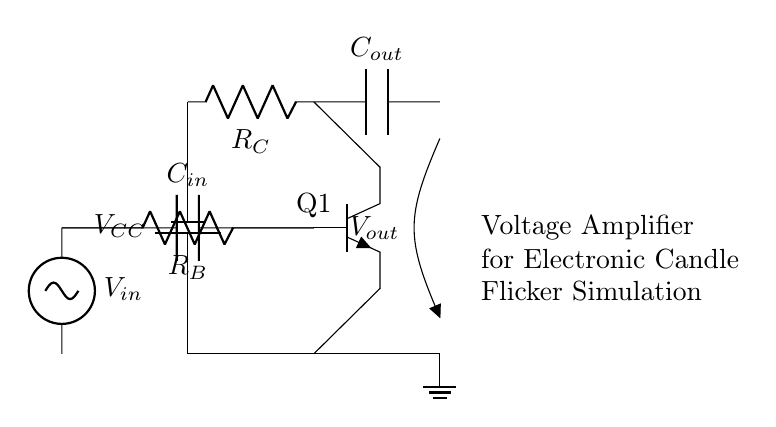What is the input voltage of the circuit? The input voltage is labeled as V_in, but the exact value is not shown in the circuit diagram. It represents the variable input that will be amplified.
Answer: V_in What type of transistor is used? The transistor label indicates that it is an NPN transistor (Q1), which is commonly used for amplification in circuits.
Answer: NPN What does the output capacitor do? The output capacitor (C_out) is used to couple the amplified signal to the load while blocking any DC voltage, only allowing AC variations to pass through.
Answer: Coupling What is the role of resistor R_B? Resistor R_B is connected between the base of the transistor and the input voltage, helping to provide the necessary bias current for the transistor to operate in its active region.
Answer: Biasing How many resistors are present in the circuit? There are two resistors present in the circuit: R_B and R_C, which are used for biasing and defining the collector current, respectively.
Answer: Two What is the purpose of capacitors C_in and C_out? Capacitor C_in allows the input signal to pass to the base of the transistor while blocking DC from the previous stage, and C_out allows the output signal to reach the load while blocking any DC component.
Answer: Coupling and blocking What is the function of the voltage amplifier in this circuit? The voltage amplifier increases the amplitude of the input voltage, simulating the flicker effect of an electronic candle light by providing a variable output based on the input signal.
Answer: Amplification 